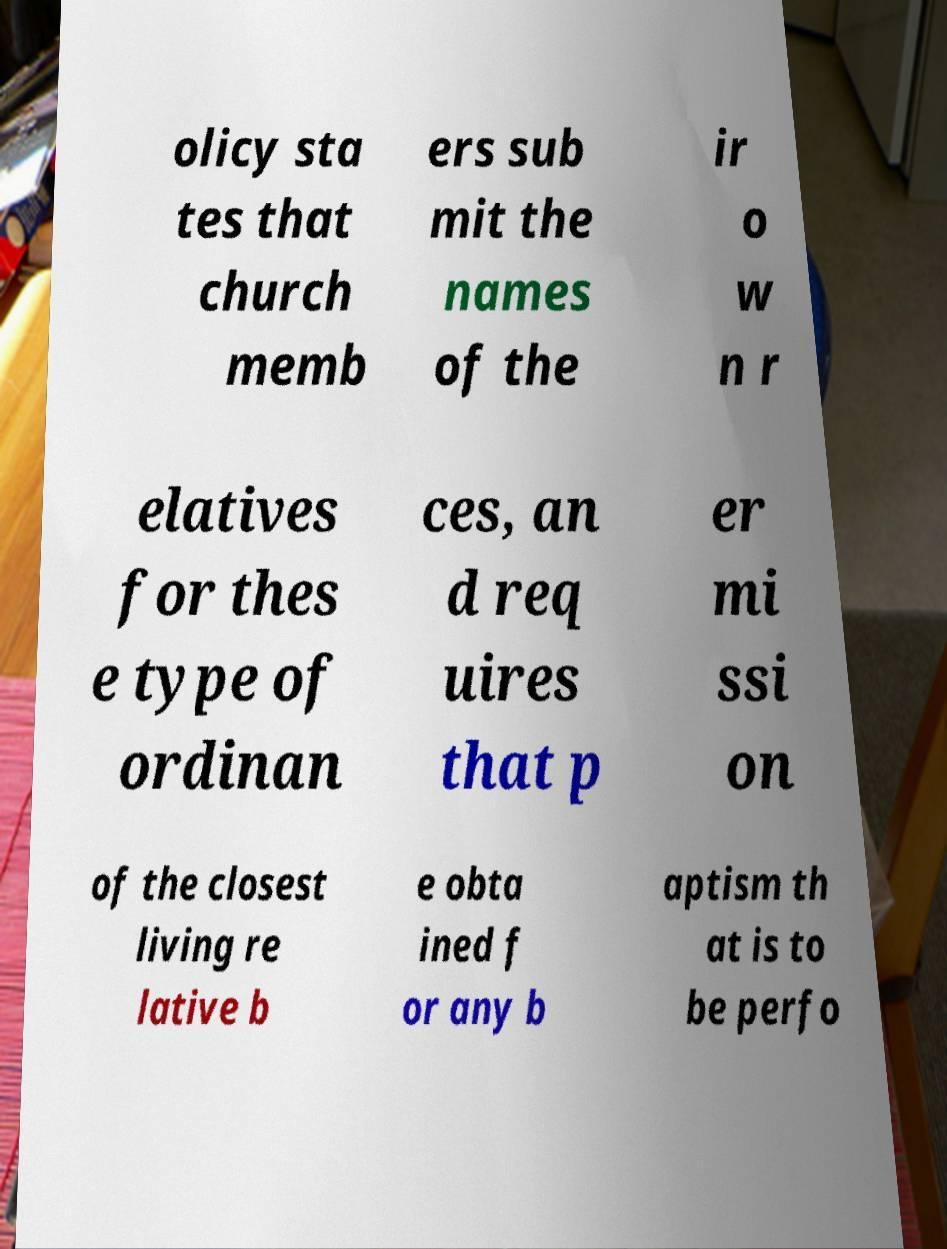Please identify and transcribe the text found in this image. olicy sta tes that church memb ers sub mit the names of the ir o w n r elatives for thes e type of ordinan ces, an d req uires that p er mi ssi on of the closest living re lative b e obta ined f or any b aptism th at is to be perfo 